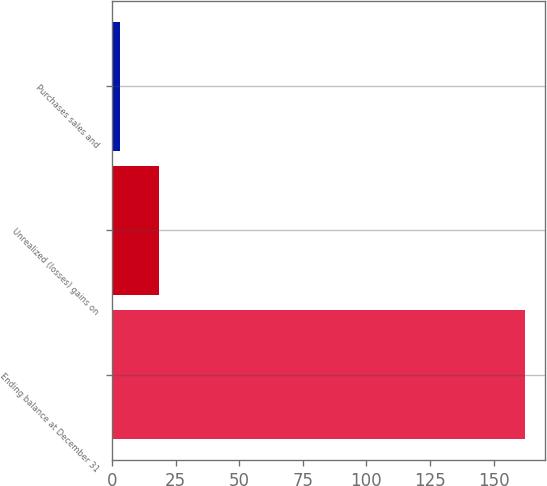Convert chart. <chart><loc_0><loc_0><loc_500><loc_500><bar_chart><fcel>Ending balance at December 31<fcel>Unrealized (losses) gains on<fcel>Purchases sales and<nl><fcel>162.3<fcel>18.3<fcel>3<nl></chart> 